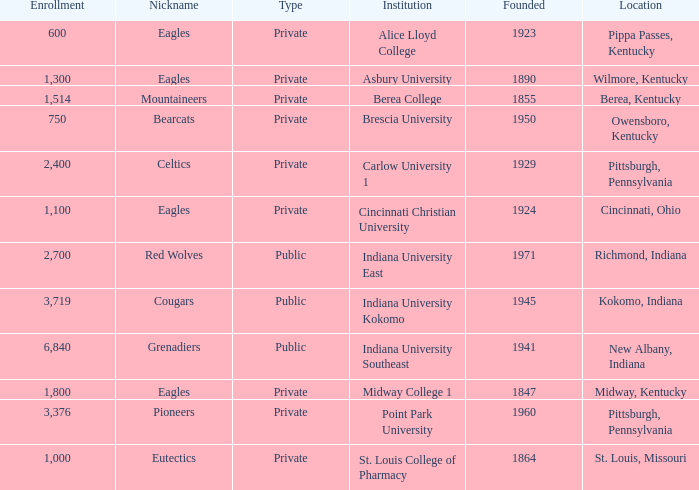Which public college has a nickname of The Grenadiers? Indiana University Southeast. 